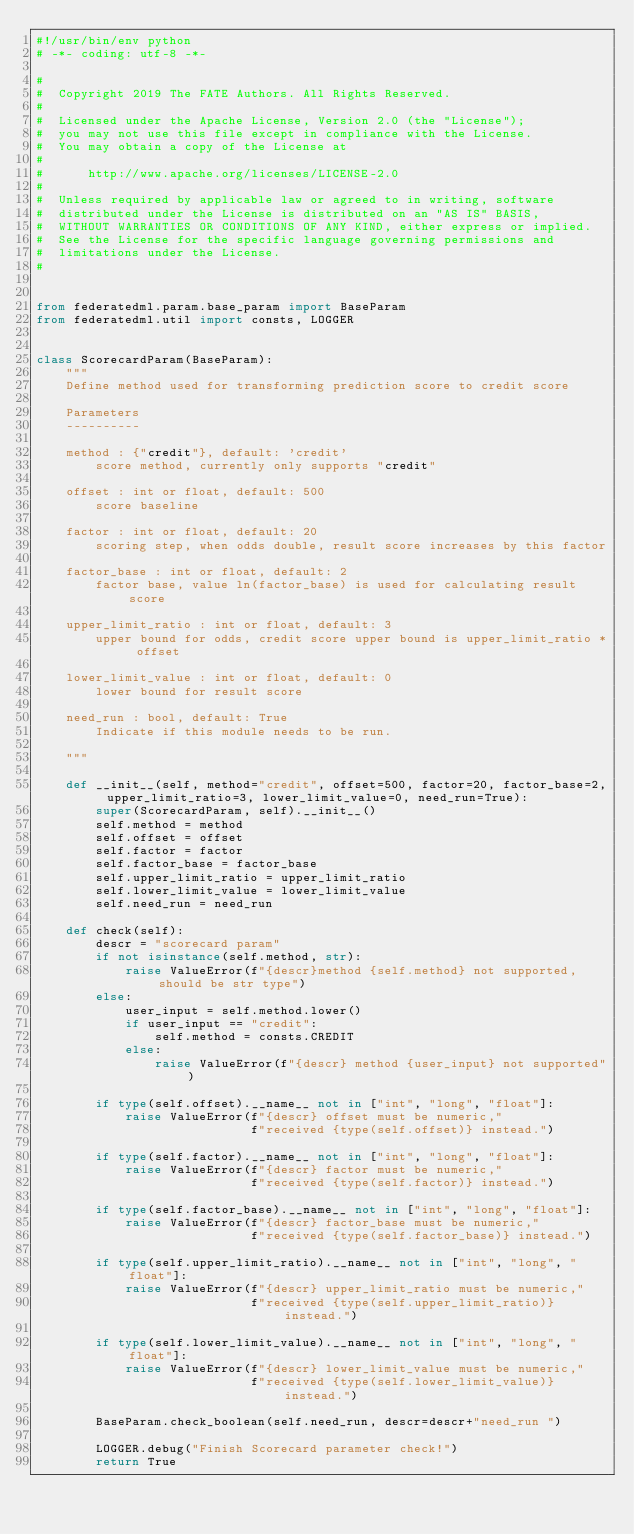Convert code to text. <code><loc_0><loc_0><loc_500><loc_500><_Python_>#!/usr/bin/env python
# -*- coding: utf-8 -*-

#
#  Copyright 2019 The FATE Authors. All Rights Reserved.
#
#  Licensed under the Apache License, Version 2.0 (the "License");
#  you may not use this file except in compliance with the License.
#  You may obtain a copy of the License at
#
#      http://www.apache.org/licenses/LICENSE-2.0
#
#  Unless required by applicable law or agreed to in writing, software
#  distributed under the License is distributed on an "AS IS" BASIS,
#  WITHOUT WARRANTIES OR CONDITIONS OF ANY KIND, either express or implied.
#  See the License for the specific language governing permissions and
#  limitations under the License.
#


from federatedml.param.base_param import BaseParam
from federatedml.util import consts, LOGGER


class ScorecardParam(BaseParam):
    """
    Define method used for transforming prediction score to credit score

    Parameters
    ----------

    method : {"credit"}, default: 'credit'
        score method, currently only supports "credit"

    offset : int or float, default: 500
        score baseline

    factor : int or float, default: 20
        scoring step, when odds double, result score increases by this factor

    factor_base : int or float, default: 2
        factor base, value ln(factor_base) is used for calculating result score

    upper_limit_ratio : int or float, default: 3
        upper bound for odds, credit score upper bound is upper_limit_ratio * offset

    lower_limit_value : int or float, default: 0
        lower bound for result score

    need_run : bool, default: True
        Indicate if this module needs to be run.

    """

    def __init__(self, method="credit", offset=500, factor=20, factor_base=2, upper_limit_ratio=3, lower_limit_value=0, need_run=True):
        super(ScorecardParam, self).__init__()
        self.method = method
        self.offset = offset
        self.factor = factor
        self.factor_base = factor_base
        self.upper_limit_ratio = upper_limit_ratio
        self.lower_limit_value = lower_limit_value
        self.need_run = need_run

    def check(self):
        descr = "scorecard param"
        if not isinstance(self.method, str):
            raise ValueError(f"{descr}method {self.method} not supported, should be str type")
        else:
            user_input = self.method.lower()
            if user_input == "credit":
                self.method = consts.CREDIT
            else:
                raise ValueError(f"{descr} method {user_input} not supported")

        if type(self.offset).__name__ not in ["int", "long", "float"]:
            raise ValueError(f"{descr} offset must be numeric,"
                             f"received {type(self.offset)} instead.")

        if type(self.factor).__name__ not in ["int", "long", "float"]:
            raise ValueError(f"{descr} factor must be numeric,"
                             f"received {type(self.factor)} instead.")

        if type(self.factor_base).__name__ not in ["int", "long", "float"]:
            raise ValueError(f"{descr} factor_base must be numeric,"
                             f"received {type(self.factor_base)} instead.")

        if type(self.upper_limit_ratio).__name__ not in ["int", "long", "float"]:
            raise ValueError(f"{descr} upper_limit_ratio must be numeric,"
                             f"received {type(self.upper_limit_ratio)} instead.")

        if type(self.lower_limit_value).__name__ not in ["int", "long", "float"]:
            raise ValueError(f"{descr} lower_limit_value must be numeric,"
                             f"received {type(self.lower_limit_value)} instead.")

        BaseParam.check_boolean(self.need_run, descr=descr+"need_run ")

        LOGGER.debug("Finish Scorecard parameter check!")
        return True
</code> 